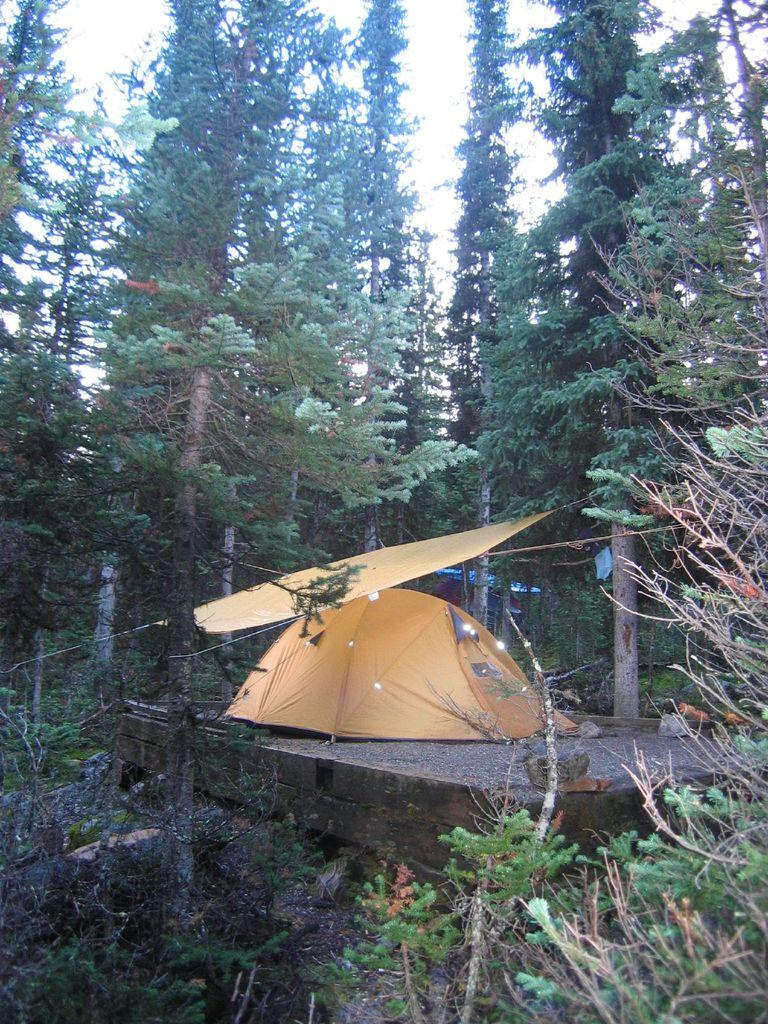What type of vegetation is present in the image? There are tall trees in the image. What type of structure can be seen on the ground in the image? There is a tent built on the ground in the image. How much salt is present in the image? There is no salt present in the image. Is there a person sleeping inside the tent in the image? The image does not show any people, so it cannot be determined if someone is sleeping inside the tent. 